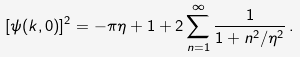<formula> <loc_0><loc_0><loc_500><loc_500>[ \psi ( k , 0 ) ] ^ { 2 } = - \pi \eta + 1 + 2 \sum _ { n = 1 } ^ { \infty } \frac { 1 } { 1 + n ^ { 2 } / \eta ^ { 2 } } \, .</formula> 